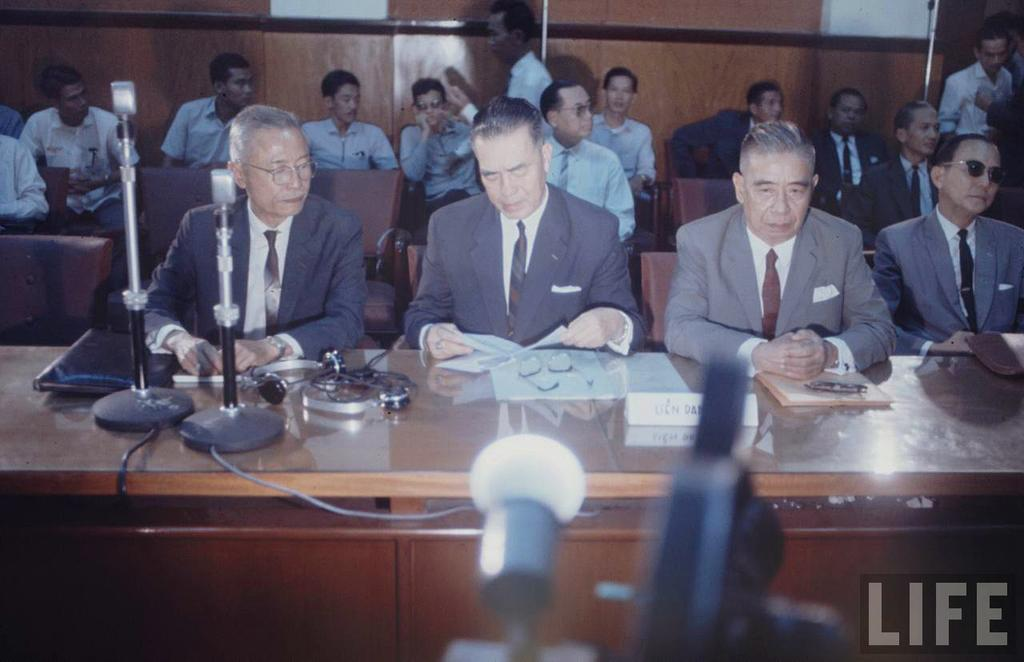How many people are in the image? There is a group of people in the image. What are the people doing in the image? The people are sitting on chairs. Where are the chairs located in relation to the table? The chairs are in front of a table. What can be seen on the table in the image? There is a microphone on the table, as well as other objects. What is the name of the mom in the image? There is no mention of a mom or any specific individuals in the image. 